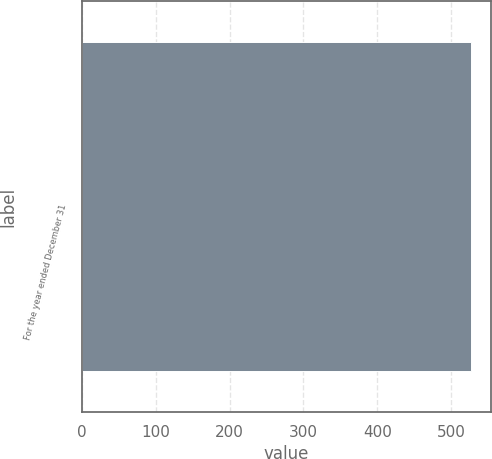<chart> <loc_0><loc_0><loc_500><loc_500><bar_chart><fcel>For the year ended December 31<nl><fcel>527<nl></chart> 